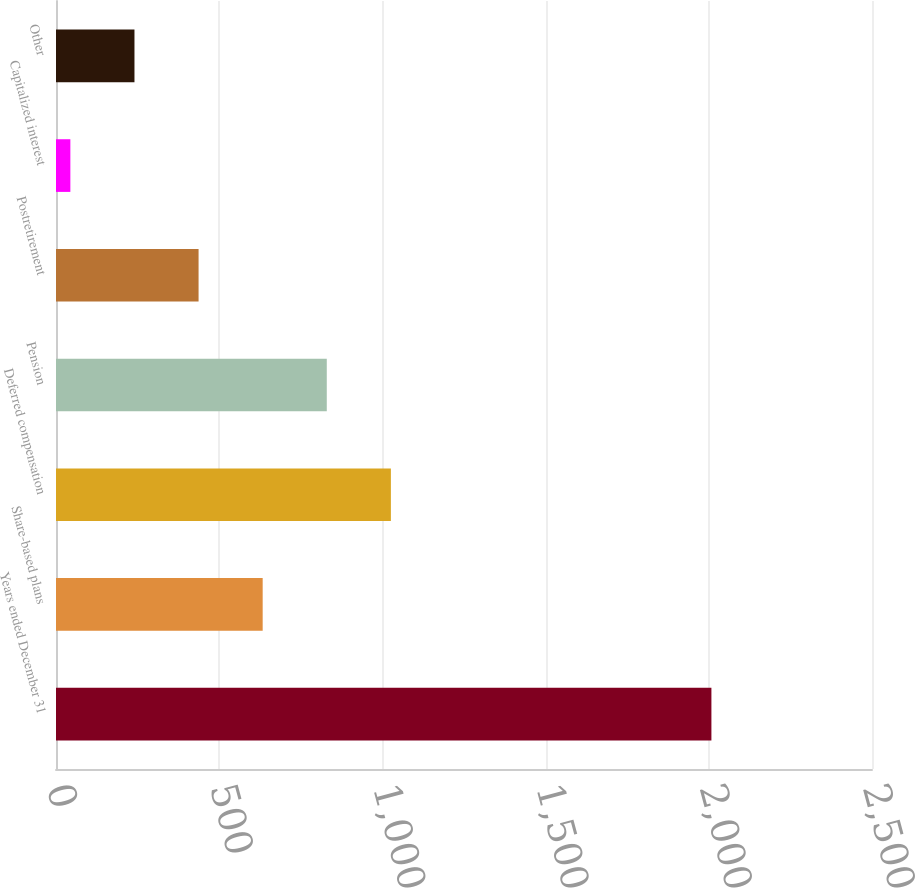<chart> <loc_0><loc_0><loc_500><loc_500><bar_chart><fcel>Years ended December 31<fcel>Share-based plans<fcel>Deferred compensation<fcel>Pension<fcel>Postretirement<fcel>Capitalized interest<fcel>Other<nl><fcel>2008<fcel>633.2<fcel>1026<fcel>829.6<fcel>436.8<fcel>44<fcel>240.4<nl></chart> 